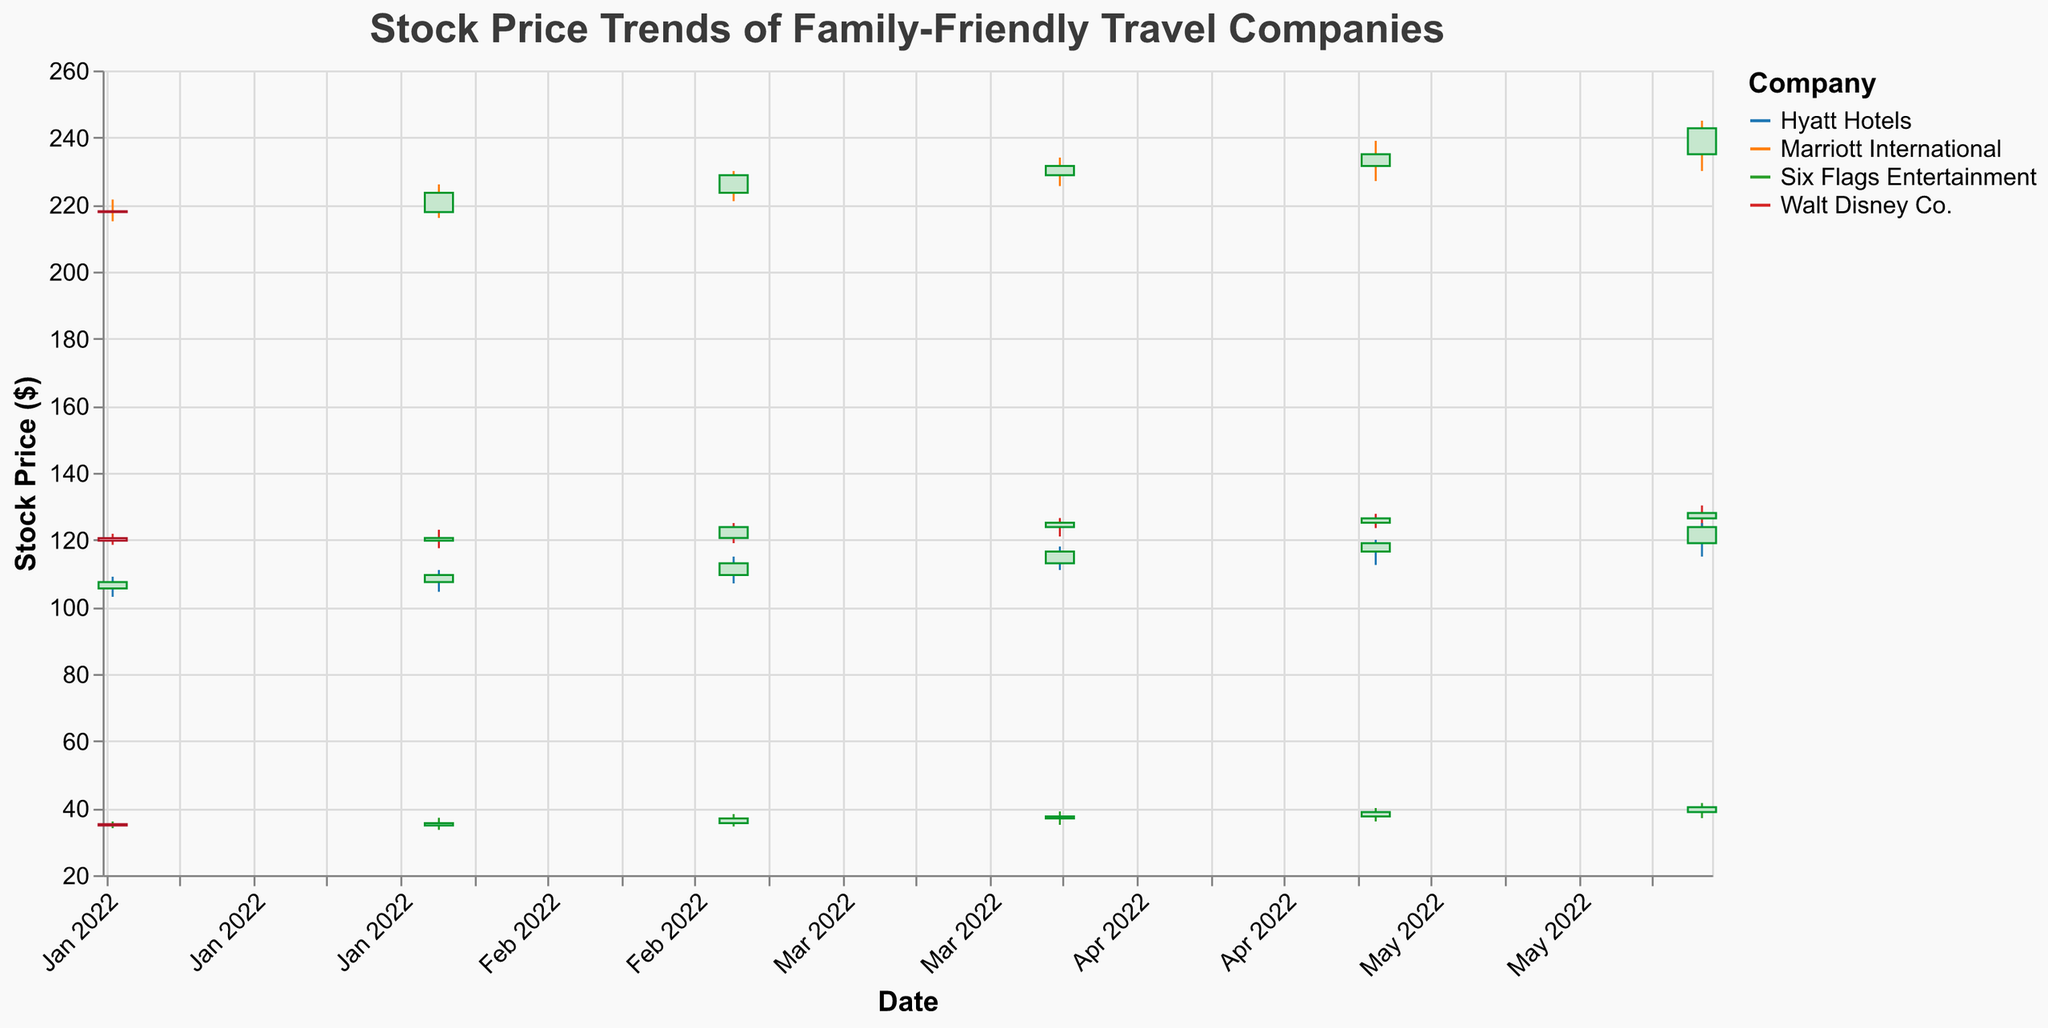what's the highest stock price for Walt Disney Co. in the first half of 2022? The highest stock price for Walt Disney Co. is observed by checking the highest points on the plot for each month in the first half of 2022. The company had its peak at 130.25 in June.
Answer: 130.25 what's the median closing price of Walt Disney Co. from January to June 2022? To find the median closing price, we order the closing prices from January to June: 119.75, 120.55, 123.80, 125.10, 126.40, 128.00. The median is the average of the third and fourth values: (123.80 + 125.10) / 2 = 124.45.
Answer: 124.45 which company has the highest stock price overall in June 2022? In June 2022, we compare the highest stock prices of each company: Walt Disney Co. (130.25), Six Flags Entertainment (41.50), Marriott International (245.00), Hyatt Hotels (125.00). Marriott International had the highest at 245.00.
Answer: Marriott International did any company's stock always close higher than it opened every month in the first half of 2022? To answer this, check each company's monthly open and close prices. Marriott International's closing prices were higher than the opening prices each month: 217.75 < 223.50, 223.50 < 228.75, 228.75 < 231.50, 231.50 < 235.00, 235.00 < 242.75.
Answer: Marriott International which company showed the greatest increase in closing price from January to June 2022? Calculate the difference between June and January closing prices for each company: Walt Disney Co. (128.00 - 119.75 = 8.25), Six Flags Entertainment (40.25 - 34.80 = 5.45), Marriott International (242.75 - 217.75 = 25.00), Hyatt Hotels (123.80 - 107.40 = 16.40). Marriott International had the greatest increase.
Answer: Marriott International what was the closing price range of Six Flags Entertainment throughout the first half of 2022? To find the range, subtract the lowest closing price from the highest closing price of Six Flags Entertainment: Highest (40.25), Lowest (34.80), Range = 40.25 - 34.80 = 5.45.
Answer: 5.45 how many times did Hyatt Hotels close at a price lower than it opened in the first half of 2022? Check each month's open and close prices and count the instances where the closing price was lower: None of the closing prices were lower than the openings for Hyatt Hotels: January (107.40 > 105.50), February (109.50 > 107.40), March (113.00 > 109.50), April (116.50 > 113.00), May (119.00 > 116.50), June (123.80 > 119.00).
Answer: 0 